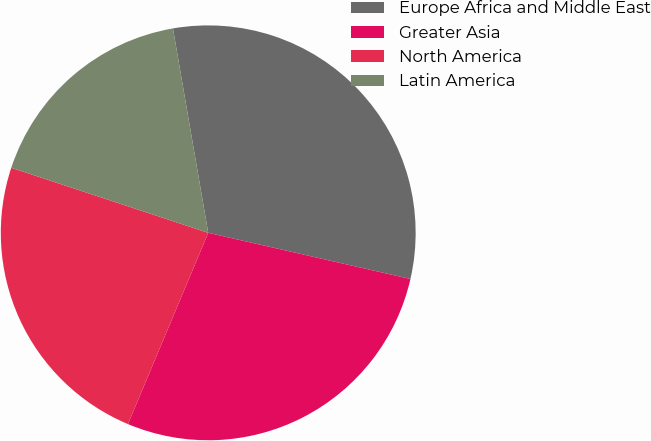Convert chart. <chart><loc_0><loc_0><loc_500><loc_500><pie_chart><fcel>Europe Africa and Middle East<fcel>Greater Asia<fcel>North America<fcel>Latin America<nl><fcel>31.29%<fcel>27.75%<fcel>23.75%<fcel>17.2%<nl></chart> 